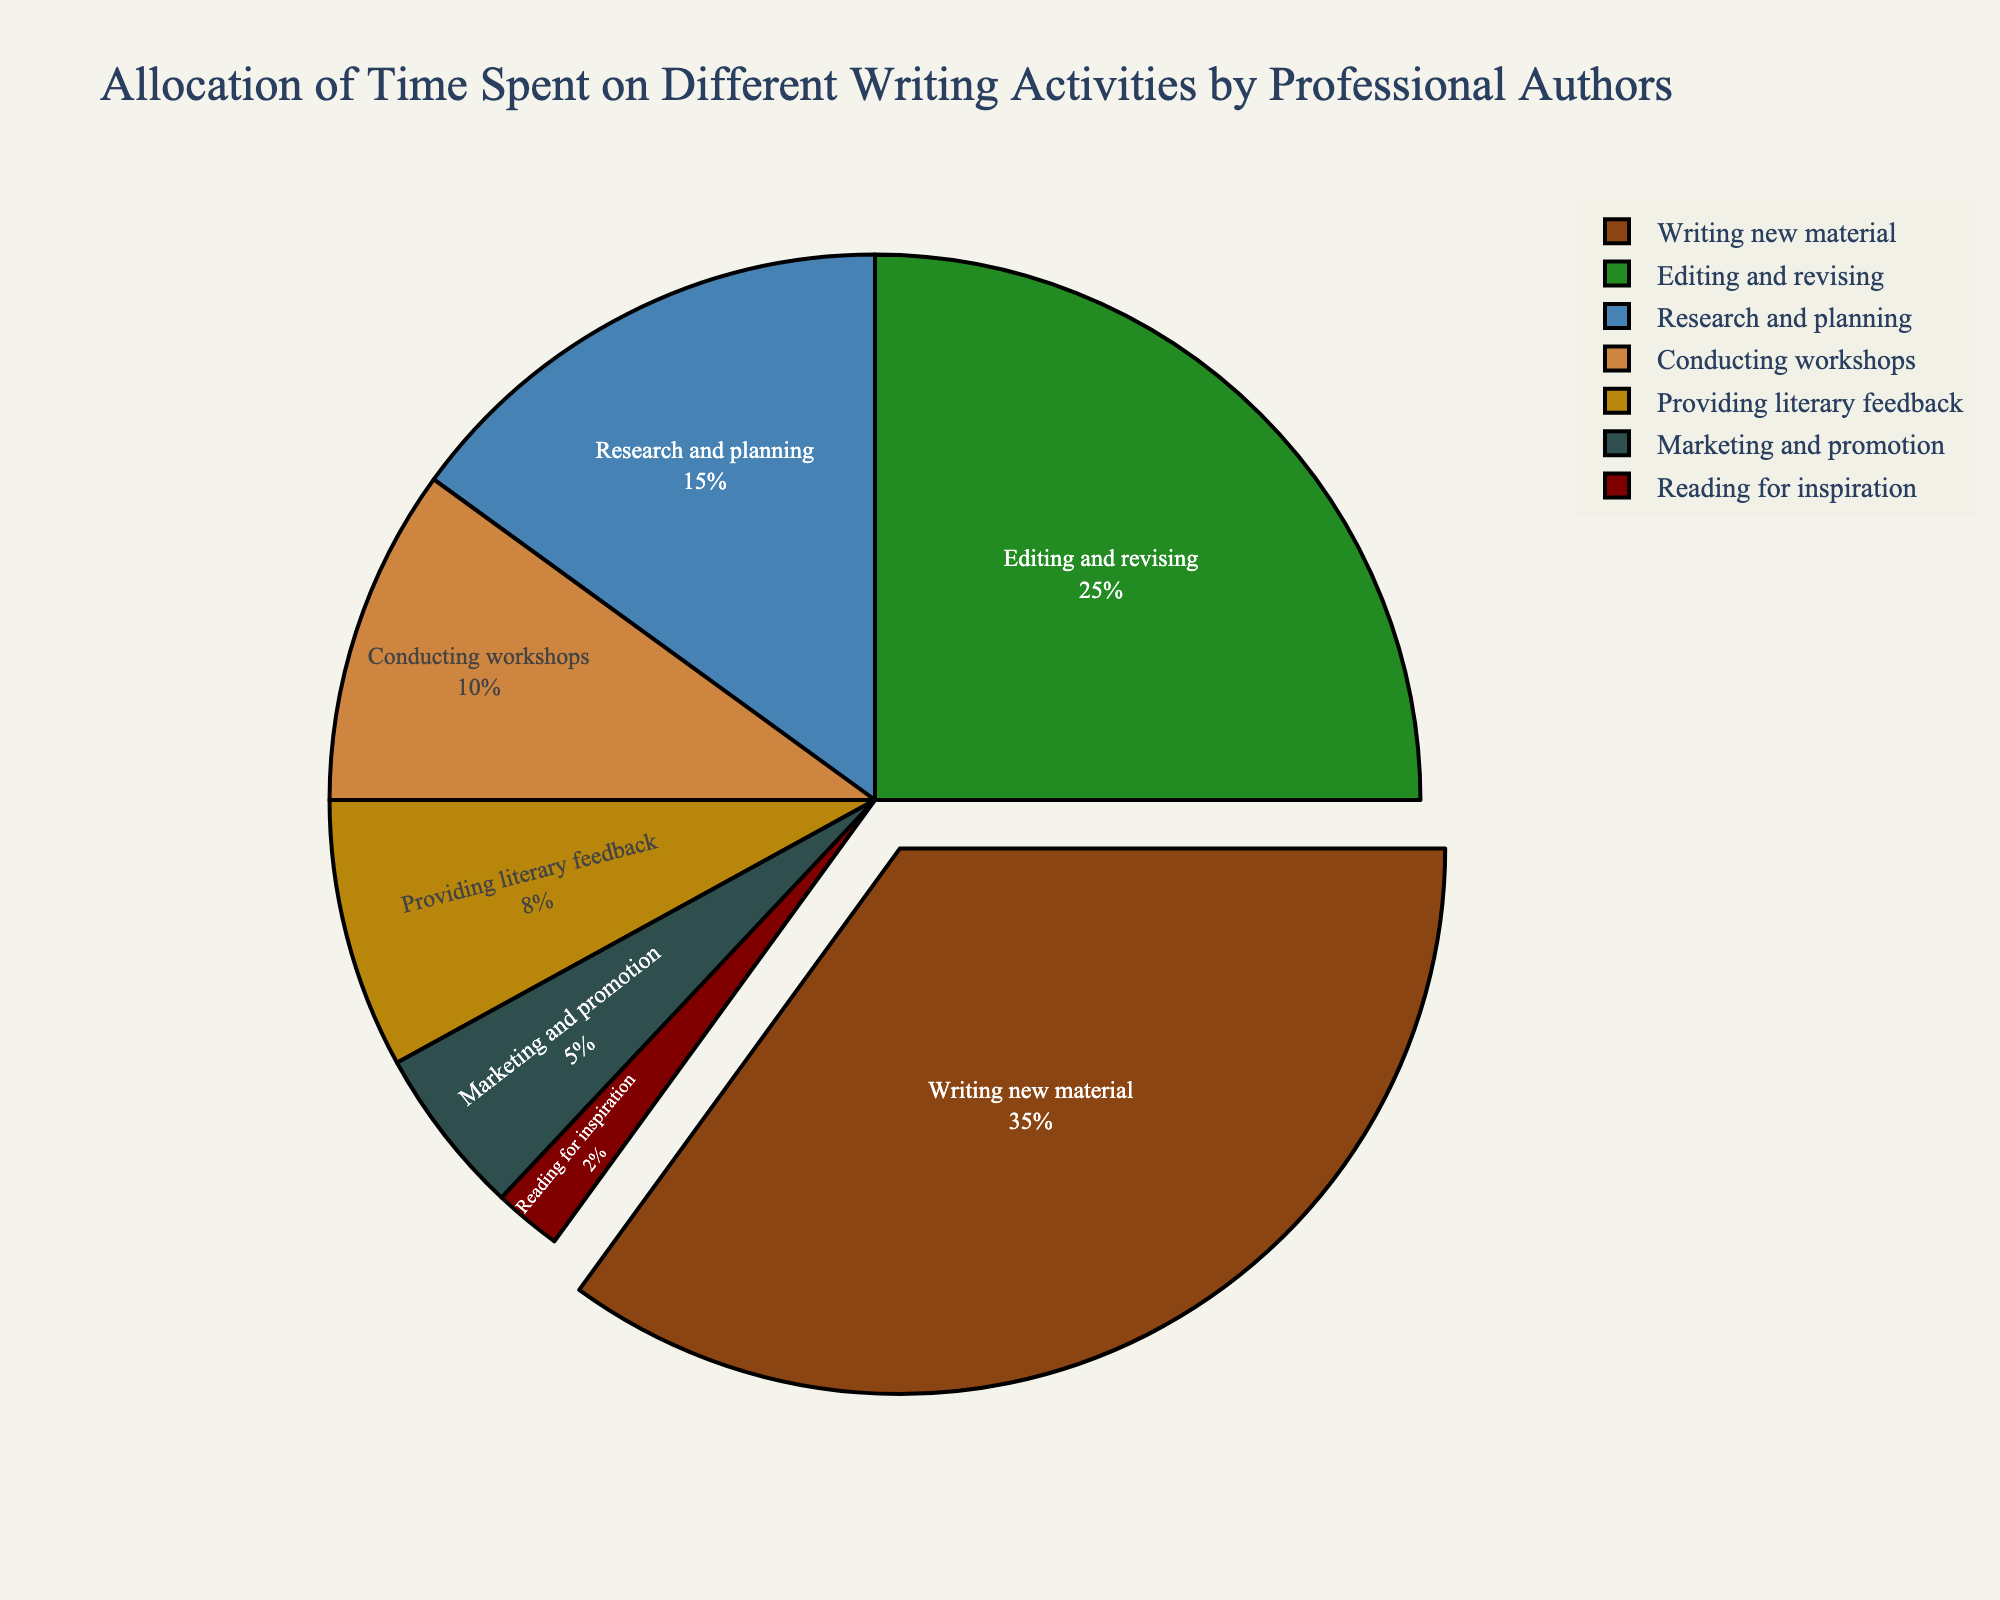what percentage of time is allocated to marketing and promotion? Locate the segment labeled "Marketing and promotion" in the pie chart and read the associated percentage
Answer: 5% which activity has the largest allocation of time? Identify the largest segment in the pie chart, which is labeled "Writing new material" with the highest percentage.
Answer: Writing new material how much more time is spent on editing and revising compared to providing literary feedback? Find the segments for "Editing and revising" and "Providing literary feedback." Subtract the percentage for "Providing literary feedback" (8%) from the percentage for "Editing and revising" (25%). 25% - 8% = 17%
Answer: 17% what is the combined percentage of time spent on research and planning and conducting workshops? Locate the segments for "Research and planning" and "Conducting workshops." Sum their percentages: 15% + 10% = 25%
Answer: 25% order the activities from the least time allocated to the most time allocated? Starting from the smallest percentage, list the activities: "Reading for inspiration" (2%), "Marketing and promotion" (5%), "Providing literary feedback" (8%), "Conducting workshops" (10%), "Research and planning" (15%), "Editing and revising" (25%), and "Writing new material" (35%).
Answer: Reading for inspiration, Marketing and promotion, Providing literary feedback, Conducting workshops, Research and planning, Editing and revising, Writing new material is more time spent on editing and revising or on research and planning combined with conducting workshops? Compare the percentage for "Editing and revising" (25%) with the combined percentage for "Research and planning" (15%) and "Conducting workshops" (10%): 15% + 10% = 25%. Both are equal at 25%.
Answer: Equal which activity has the smallest allocation of time? Identify the smallest segment in the pie chart, which is labeled "Reading for inspiration" with the smallest percentage.
Answer: Reading for inspiration 